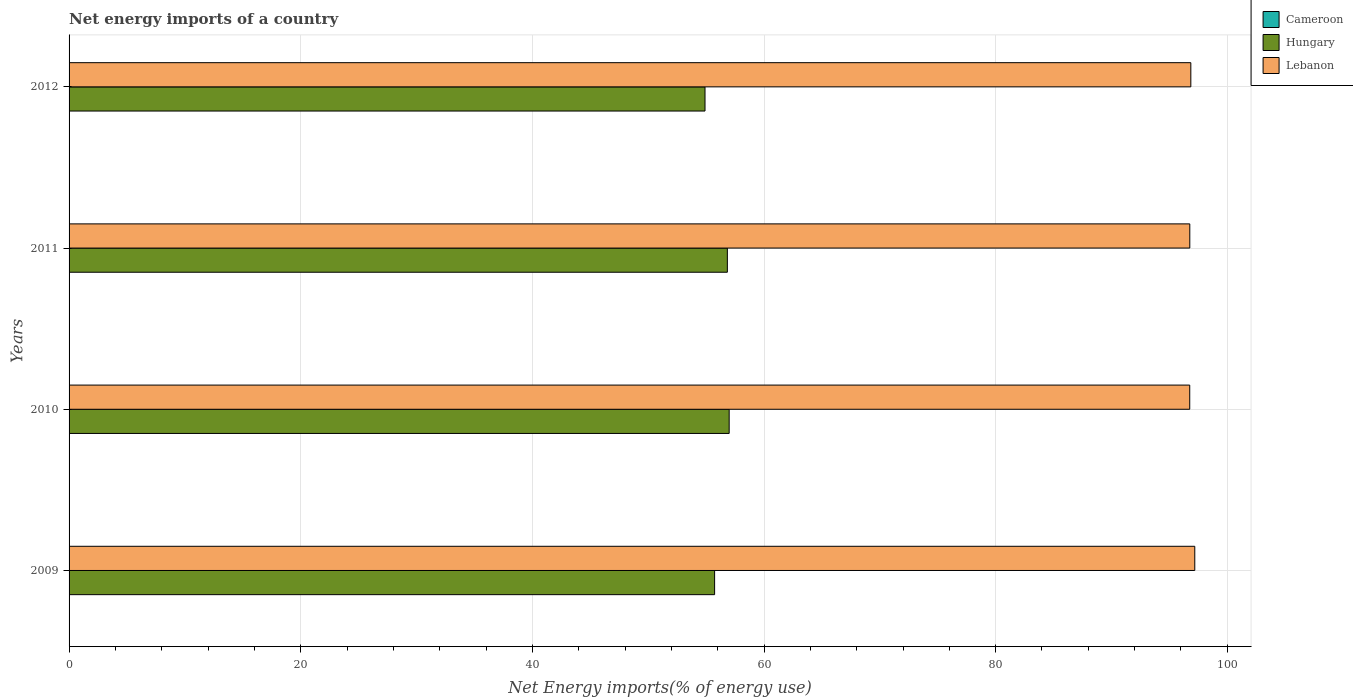How many different coloured bars are there?
Keep it short and to the point. 2. How many groups of bars are there?
Give a very brief answer. 4. Are the number of bars per tick equal to the number of legend labels?
Provide a succinct answer. No. Are the number of bars on each tick of the Y-axis equal?
Your response must be concise. Yes. How many bars are there on the 2nd tick from the top?
Ensure brevity in your answer.  2. How many bars are there on the 2nd tick from the bottom?
Make the answer very short. 2. What is the label of the 2nd group of bars from the top?
Offer a very short reply. 2011. In how many cases, is the number of bars for a given year not equal to the number of legend labels?
Provide a succinct answer. 4. What is the net energy imports in Lebanon in 2011?
Provide a succinct answer. 96.76. Across all years, what is the maximum net energy imports in Lebanon?
Your response must be concise. 97.19. Across all years, what is the minimum net energy imports in Lebanon?
Your response must be concise. 96.76. What is the difference between the net energy imports in Lebanon in 2010 and that in 2011?
Your response must be concise. -0. What is the difference between the net energy imports in Lebanon in 2010 and the net energy imports in Cameroon in 2011?
Keep it short and to the point. 96.76. What is the average net energy imports in Lebanon per year?
Your answer should be very brief. 96.89. In the year 2009, what is the difference between the net energy imports in Hungary and net energy imports in Lebanon?
Make the answer very short. -41.46. What is the ratio of the net energy imports in Hungary in 2009 to that in 2011?
Offer a very short reply. 0.98. What is the difference between the highest and the second highest net energy imports in Hungary?
Your answer should be compact. 0.16. What is the difference between the highest and the lowest net energy imports in Hungary?
Your answer should be very brief. 2.09. In how many years, is the net energy imports in Cameroon greater than the average net energy imports in Cameroon taken over all years?
Ensure brevity in your answer.  0. Are all the bars in the graph horizontal?
Provide a short and direct response. Yes. How many years are there in the graph?
Offer a very short reply. 4. What is the difference between two consecutive major ticks on the X-axis?
Offer a terse response. 20. Are the values on the major ticks of X-axis written in scientific E-notation?
Make the answer very short. No. Does the graph contain grids?
Your answer should be very brief. Yes. Where does the legend appear in the graph?
Your response must be concise. Top right. How are the legend labels stacked?
Offer a terse response. Vertical. What is the title of the graph?
Your answer should be compact. Net energy imports of a country. What is the label or title of the X-axis?
Your response must be concise. Net Energy imports(% of energy use). What is the label or title of the Y-axis?
Your answer should be compact. Years. What is the Net Energy imports(% of energy use) in Hungary in 2009?
Your answer should be compact. 55.74. What is the Net Energy imports(% of energy use) of Lebanon in 2009?
Keep it short and to the point. 97.19. What is the Net Energy imports(% of energy use) in Hungary in 2010?
Keep it short and to the point. 56.99. What is the Net Energy imports(% of energy use) of Lebanon in 2010?
Give a very brief answer. 96.76. What is the Net Energy imports(% of energy use) in Cameroon in 2011?
Provide a succinct answer. 0. What is the Net Energy imports(% of energy use) of Hungary in 2011?
Provide a short and direct response. 56.84. What is the Net Energy imports(% of energy use) of Lebanon in 2011?
Make the answer very short. 96.76. What is the Net Energy imports(% of energy use) of Cameroon in 2012?
Offer a terse response. 0. What is the Net Energy imports(% of energy use) of Hungary in 2012?
Your response must be concise. 54.91. What is the Net Energy imports(% of energy use) of Lebanon in 2012?
Your answer should be compact. 96.85. Across all years, what is the maximum Net Energy imports(% of energy use) of Hungary?
Offer a terse response. 56.99. Across all years, what is the maximum Net Energy imports(% of energy use) in Lebanon?
Your response must be concise. 97.19. Across all years, what is the minimum Net Energy imports(% of energy use) in Hungary?
Your answer should be very brief. 54.91. Across all years, what is the minimum Net Energy imports(% of energy use) in Lebanon?
Keep it short and to the point. 96.76. What is the total Net Energy imports(% of energy use) of Cameroon in the graph?
Your answer should be compact. 0. What is the total Net Energy imports(% of energy use) in Hungary in the graph?
Your answer should be compact. 224.47. What is the total Net Energy imports(% of energy use) in Lebanon in the graph?
Offer a very short reply. 387.56. What is the difference between the Net Energy imports(% of energy use) in Hungary in 2009 and that in 2010?
Provide a short and direct response. -1.26. What is the difference between the Net Energy imports(% of energy use) of Lebanon in 2009 and that in 2010?
Provide a succinct answer. 0.44. What is the difference between the Net Energy imports(% of energy use) of Hungary in 2009 and that in 2011?
Provide a succinct answer. -1.1. What is the difference between the Net Energy imports(% of energy use) in Lebanon in 2009 and that in 2011?
Provide a short and direct response. 0.43. What is the difference between the Net Energy imports(% of energy use) in Hungary in 2009 and that in 2012?
Give a very brief answer. 0.83. What is the difference between the Net Energy imports(% of energy use) of Lebanon in 2009 and that in 2012?
Ensure brevity in your answer.  0.34. What is the difference between the Net Energy imports(% of energy use) in Hungary in 2010 and that in 2011?
Provide a short and direct response. 0.16. What is the difference between the Net Energy imports(% of energy use) of Lebanon in 2010 and that in 2011?
Make the answer very short. -0. What is the difference between the Net Energy imports(% of energy use) in Hungary in 2010 and that in 2012?
Keep it short and to the point. 2.09. What is the difference between the Net Energy imports(% of energy use) in Lebanon in 2010 and that in 2012?
Your answer should be compact. -0.09. What is the difference between the Net Energy imports(% of energy use) of Hungary in 2011 and that in 2012?
Offer a very short reply. 1.93. What is the difference between the Net Energy imports(% of energy use) in Lebanon in 2011 and that in 2012?
Your answer should be very brief. -0.09. What is the difference between the Net Energy imports(% of energy use) of Hungary in 2009 and the Net Energy imports(% of energy use) of Lebanon in 2010?
Your answer should be very brief. -41.02. What is the difference between the Net Energy imports(% of energy use) of Hungary in 2009 and the Net Energy imports(% of energy use) of Lebanon in 2011?
Make the answer very short. -41.03. What is the difference between the Net Energy imports(% of energy use) in Hungary in 2009 and the Net Energy imports(% of energy use) in Lebanon in 2012?
Your response must be concise. -41.12. What is the difference between the Net Energy imports(% of energy use) in Hungary in 2010 and the Net Energy imports(% of energy use) in Lebanon in 2011?
Give a very brief answer. -39.77. What is the difference between the Net Energy imports(% of energy use) of Hungary in 2010 and the Net Energy imports(% of energy use) of Lebanon in 2012?
Make the answer very short. -39.86. What is the difference between the Net Energy imports(% of energy use) in Hungary in 2011 and the Net Energy imports(% of energy use) in Lebanon in 2012?
Offer a very short reply. -40.02. What is the average Net Energy imports(% of energy use) of Cameroon per year?
Provide a short and direct response. 0. What is the average Net Energy imports(% of energy use) of Hungary per year?
Your answer should be very brief. 56.12. What is the average Net Energy imports(% of energy use) in Lebanon per year?
Provide a succinct answer. 96.89. In the year 2009, what is the difference between the Net Energy imports(% of energy use) in Hungary and Net Energy imports(% of energy use) in Lebanon?
Your answer should be compact. -41.46. In the year 2010, what is the difference between the Net Energy imports(% of energy use) of Hungary and Net Energy imports(% of energy use) of Lebanon?
Ensure brevity in your answer.  -39.76. In the year 2011, what is the difference between the Net Energy imports(% of energy use) in Hungary and Net Energy imports(% of energy use) in Lebanon?
Give a very brief answer. -39.93. In the year 2012, what is the difference between the Net Energy imports(% of energy use) in Hungary and Net Energy imports(% of energy use) in Lebanon?
Provide a short and direct response. -41.94. What is the ratio of the Net Energy imports(% of energy use) in Hungary in 2009 to that in 2010?
Provide a short and direct response. 0.98. What is the ratio of the Net Energy imports(% of energy use) of Lebanon in 2009 to that in 2010?
Provide a short and direct response. 1. What is the ratio of the Net Energy imports(% of energy use) of Hungary in 2009 to that in 2011?
Offer a very short reply. 0.98. What is the ratio of the Net Energy imports(% of energy use) of Hungary in 2009 to that in 2012?
Give a very brief answer. 1.02. What is the ratio of the Net Energy imports(% of energy use) in Hungary in 2010 to that in 2011?
Provide a succinct answer. 1. What is the ratio of the Net Energy imports(% of energy use) in Hungary in 2010 to that in 2012?
Provide a short and direct response. 1.04. What is the ratio of the Net Energy imports(% of energy use) of Lebanon in 2010 to that in 2012?
Your answer should be compact. 1. What is the ratio of the Net Energy imports(% of energy use) in Hungary in 2011 to that in 2012?
Offer a terse response. 1.04. What is the ratio of the Net Energy imports(% of energy use) in Lebanon in 2011 to that in 2012?
Your answer should be very brief. 1. What is the difference between the highest and the second highest Net Energy imports(% of energy use) in Hungary?
Keep it short and to the point. 0.16. What is the difference between the highest and the second highest Net Energy imports(% of energy use) of Lebanon?
Your answer should be compact. 0.34. What is the difference between the highest and the lowest Net Energy imports(% of energy use) in Hungary?
Provide a short and direct response. 2.09. What is the difference between the highest and the lowest Net Energy imports(% of energy use) in Lebanon?
Provide a short and direct response. 0.44. 